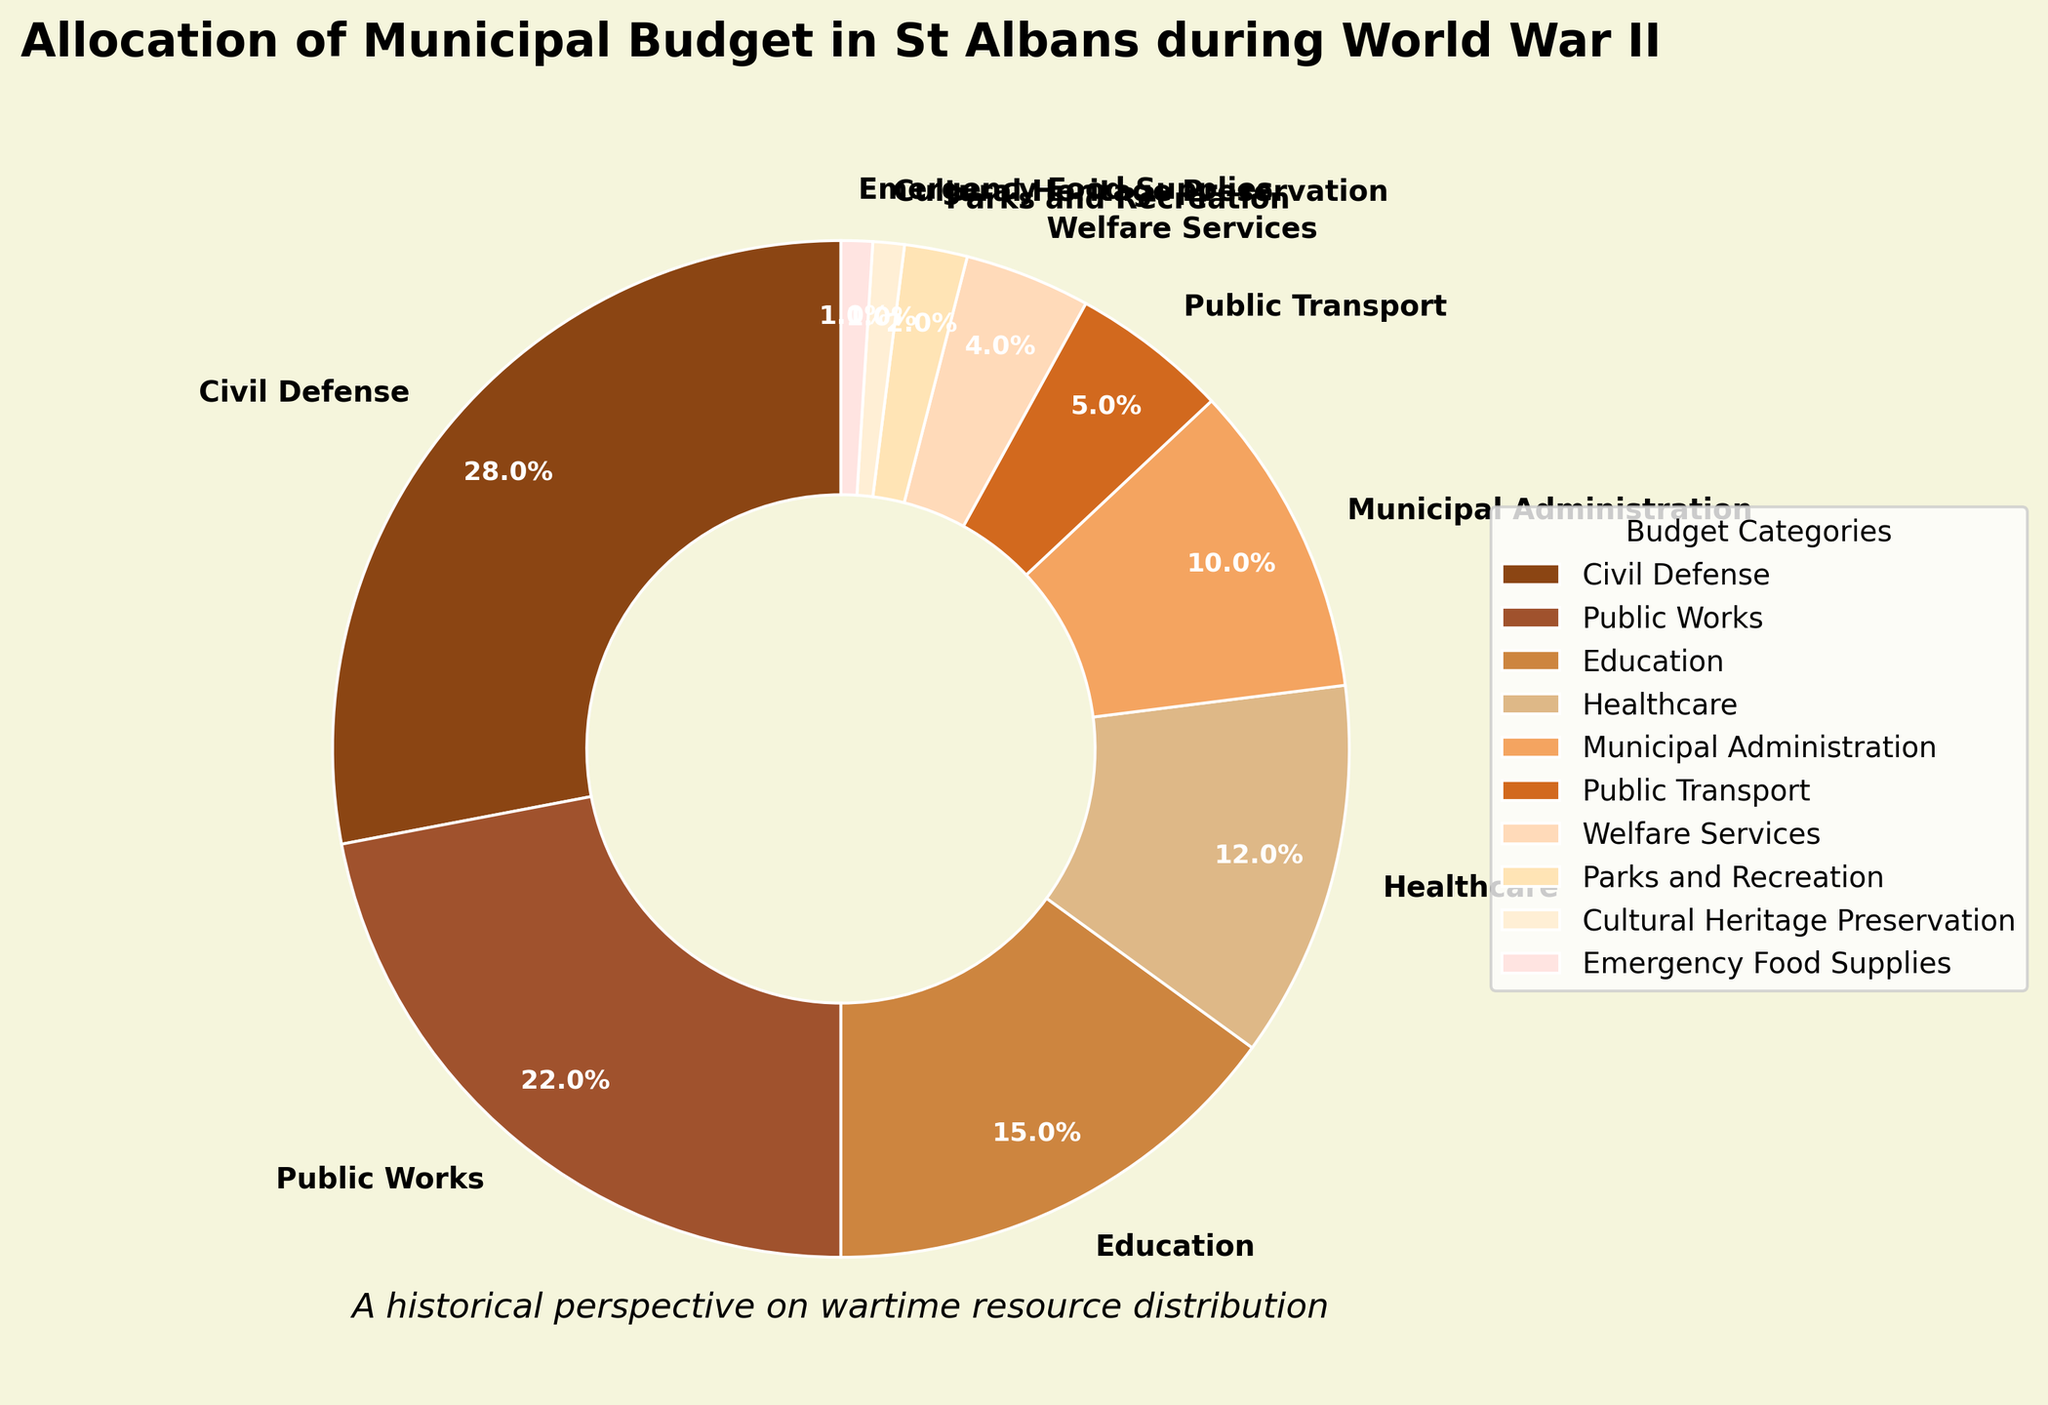Which category received the largest portion of the municipal budget? By observing the pie chart, the largest wedge represents the category receiving the most funding. Civil Defense appears to occupy the largest segment in the chart.
Answer: Civil Defense What is the combined budget percentage for Public Works and Education? Adding the percentages directly from the chart, Public Works is 22% and Education is 15%. Summing these gives 22 + 15 = 37%.
Answer: 37% Which category received the smallest portion of the municipal budget? The smallest wedge in the pie chart indicates the category with the least allocation. The category is Cultural Heritage Preservation and Emergency Food Supplies, both at 1%.
Answer: Cultural Heritage Preservation and Emergency Food Supplies How much more budget percentage did Civil Defense receive compared to Healthcare? The budget percentage for Civil Defense is 28%, and for Healthcare, it is 12%. Subtracting these values, 28 - 12 = 16%.
Answer: 16% What is the total budget allocation for categories receiving less than 5% each? According to the chart, Public Transport (5%), Welfare Services (4%), Parks and Recreation (2%), Cultural Heritage Preservation (1%), and Emergency Food Supplies (1%) are the categories to be summed. Therefore, 5 + 4 + 2 + 1 + 1 = 13%.
Answer: 13% Which two categories combined contribute to the same percentage as Civil Defense? Civil Defense is allocated 28%. Combining Public Works (22%) and Healthcare (12%) gives 22 + 12 = 34%, which is higher. Combining Public Works (22%) and Public Transport (5%) gives 22 + 5 = 27%, which is closest but not exact. Therefore, the combination of Public Works (22%) and Welfare Services (4%) gives 22 + 4 = 26%, not exact either. No exact match is found from the available data.
Answer: No exact match Compare the budget allocations between Public Works and Municipal Administration. Which one has a higher allocation and by how much? Public Works has 22%, and Municipal Administration has 10%. Subtracting these values, 22 - 10 = 12%. Public Works has a higher allocation.
Answer: Public Works by 12% If the total budget were £1,000,000, how much money would be allocated to Parks and Recreation? Parks and Recreation have a 2% allocation. Calculating 2% of £1,000,000 gives 1,000,000 * 0.02 = £20,000.
Answer: £20,000 